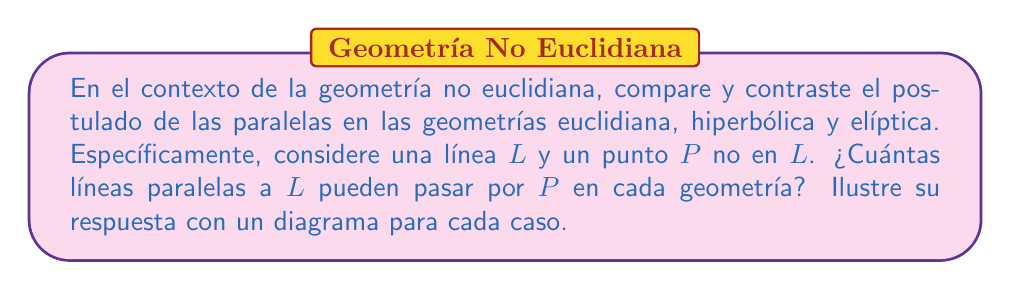Provide a solution to this math problem. Para responder a esta pregunta, analizaremos el postulado de las paralelas en cada geometría:

1. Geometría Euclidiana:
   - El postulado de las paralelas de Euclides establece que por un punto exterior a una recta pasa una y sólo una paralela a dicha recta.
   - En este caso, por el punto $P$ pasa exactamente una línea paralela a $L$.

   [asy]
   import geometry;
   size(200);
   line L = line((0,0),(100,0));
   dot("$P$", (50,50), N);
   line parallel = line((0,50),(100,50));
   draw(L);
   draw(parallel);
   label("$L$", (100,0), E);
   [/asy]

2. Geometría Hiperbólica:
   - En la geometría hiperbólica, por un punto exterior a una recta pasan infinitas paralelas a dicha recta.
   - Esto significa que por el punto $P$ pasan infinitas líneas paralelas a $L$.

   [asy]
   import geometry;
   size(200);
   path hyp_line = (0,0)..(100,0);
   draw(hyp_line);
   dot("$P$", (50,50), N);
   path p1 = (0,70)..(100,30);
   path p2 = (0,60)..(100,20);
   path p3 = (0,50)..(100,10);
   draw(p1);
   draw(p2);
   draw(p3);
   label("$L$", (100,0), E);
   [/asy]

3. Geometría Elíptica:
   - En la geometría elíptica, no existen líneas paralelas.
   - Todas las líneas que pasan por $P$ eventualmente intersectarán a $L$.
   - Por lo tanto, por el punto $P$ no pasa ninguna línea paralela a $L$.

   [asy]
   import geometry;
   size(200);
   ellipse e = ellipse((50,50),50,30);
   draw(e);
   pair P = (50,80);
   dot("$P$", P, N);
   pair A = (0,50);
   pair B = (100,50);
   draw(A--B);
   draw(P--(100,20));
   draw(P--(0,20));
   label("$L$", B, E);
   [/asy]

En resumen:
- Geometría Euclidiana: 1 paralela
- Geometría Hiperbólica: Infinitas paralelas
- Geometría Elíptica: 0 paralelas
Answer: Euclidiana: 1, Hiperbólica: $\infty$, Elíptica: 0 